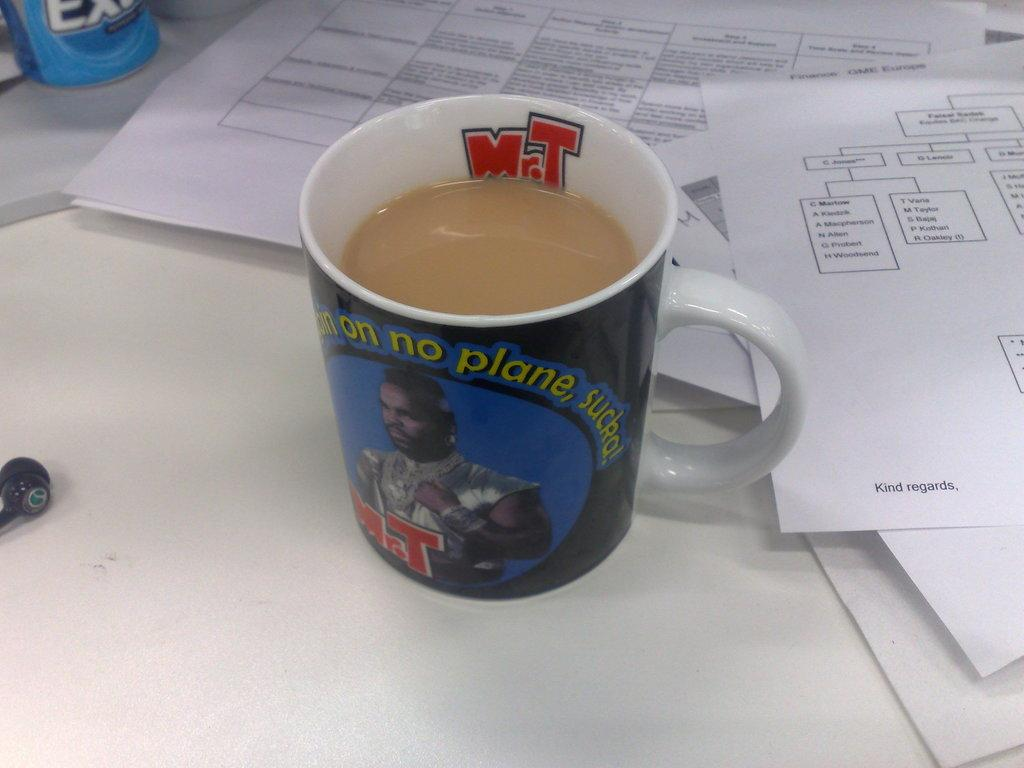<image>
Provide a brief description of the given image. A Mr. T coffee mug that says I ain't goin on no plane, sucka. 